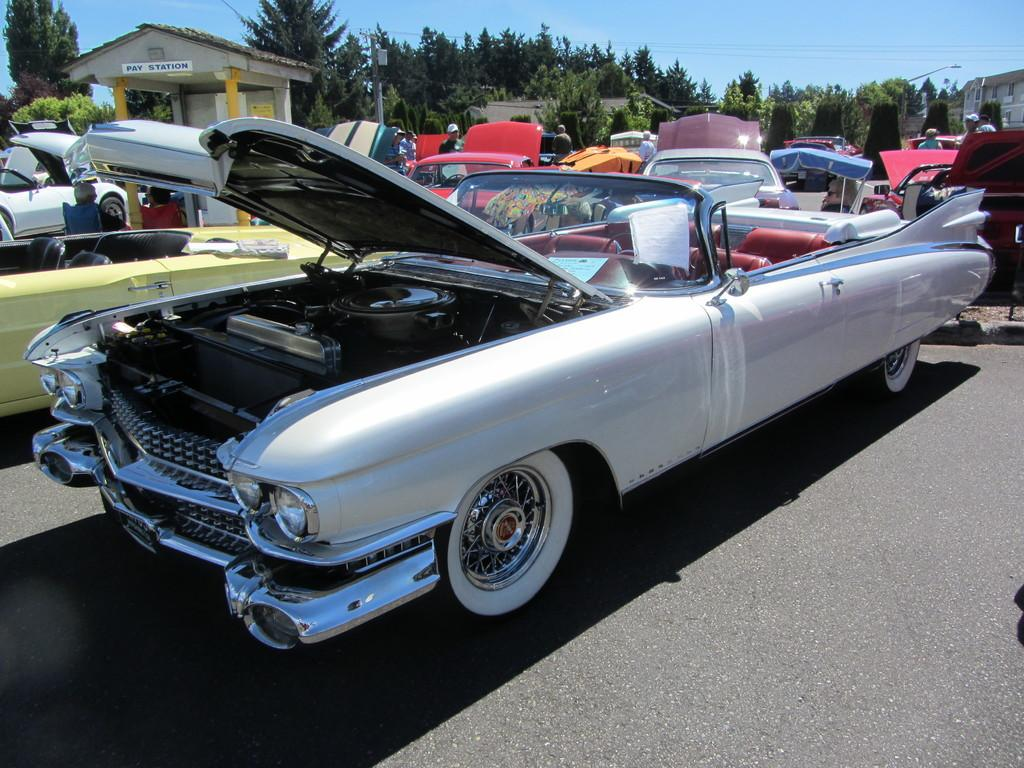What is the main subject in the foreground of the image? There are many cars in the foreground of the image. What can be seen behind the cars? There is a playstation behind the cars. What is present around the playstation? There are a lot of trees around the playstation. What type of laborer is working on the building in the image? There is no building or laborer present in the image. 